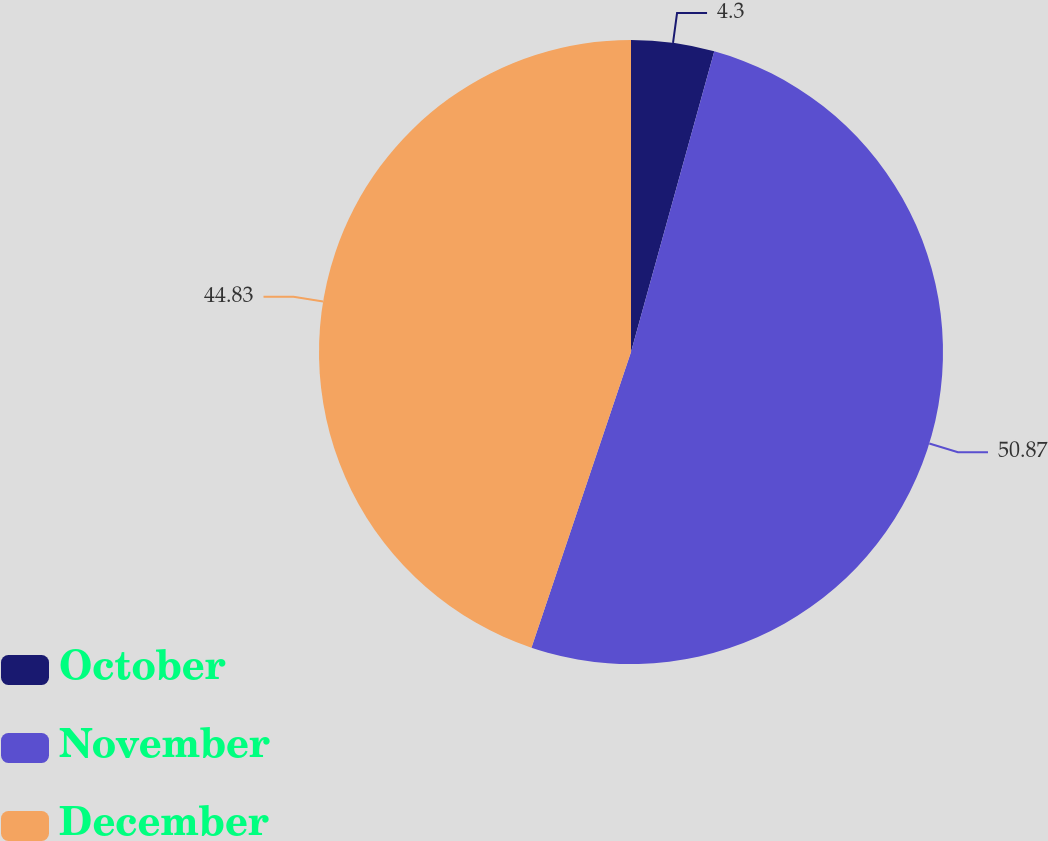Convert chart to OTSL. <chart><loc_0><loc_0><loc_500><loc_500><pie_chart><fcel>October<fcel>November<fcel>December<nl><fcel>4.3%<fcel>50.87%<fcel>44.83%<nl></chart> 